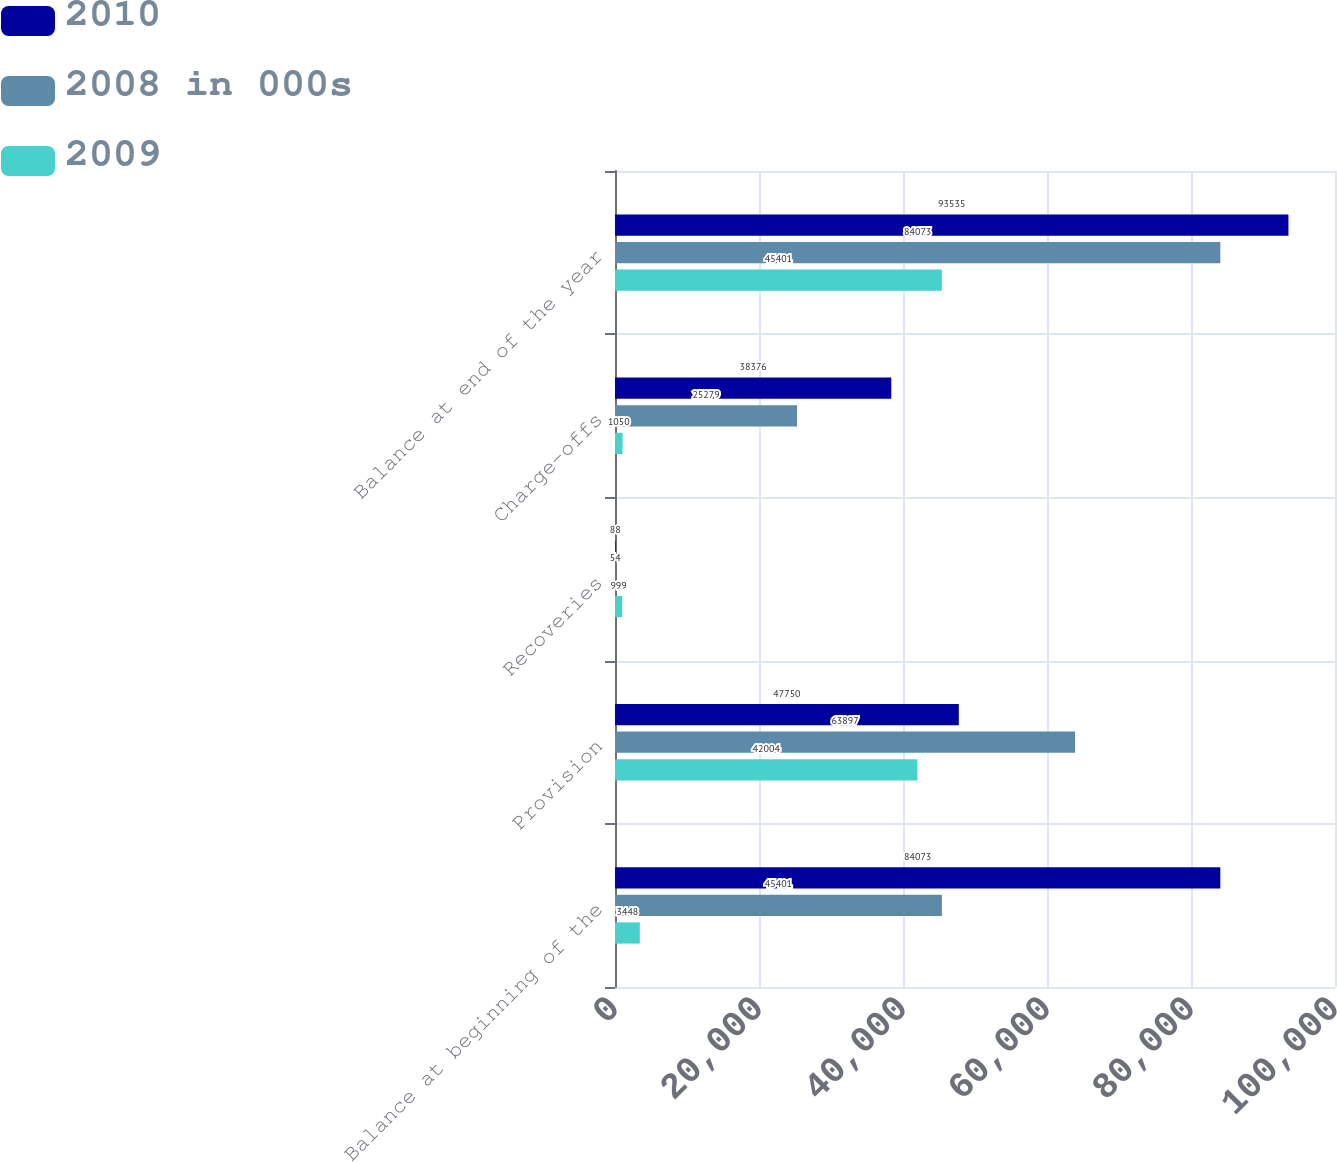<chart> <loc_0><loc_0><loc_500><loc_500><stacked_bar_chart><ecel><fcel>Balance at beginning of the<fcel>Provision<fcel>Recoveries<fcel>Charge-offs<fcel>Balance at end of the year<nl><fcel>2010<fcel>84073<fcel>47750<fcel>88<fcel>38376<fcel>93535<nl><fcel>2008 in 000s<fcel>45401<fcel>63897<fcel>54<fcel>25279<fcel>84073<nl><fcel>2009<fcel>3448<fcel>42004<fcel>999<fcel>1050<fcel>45401<nl></chart> 